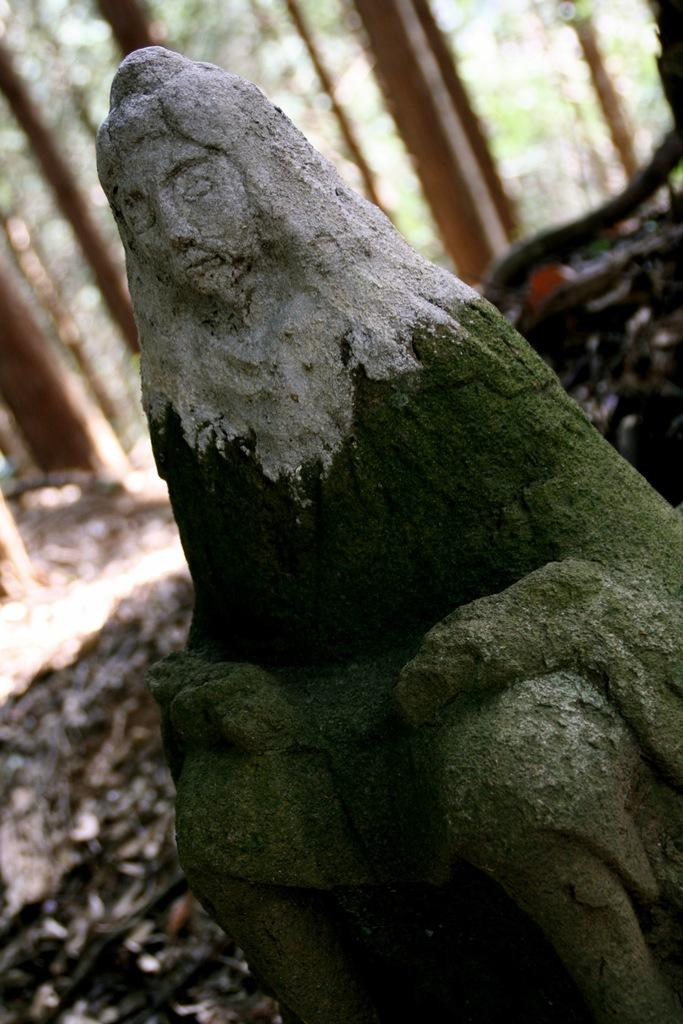What is the main subject in the foreground of the image? There is a sculpture in the foreground of the image. What can be seen in the background of the image? There are trees and the land visible in the background of the image. What type of butter is being used to create the sculpture in the image? There is no butter present in the image, and the sculpture is not being created in the image. 